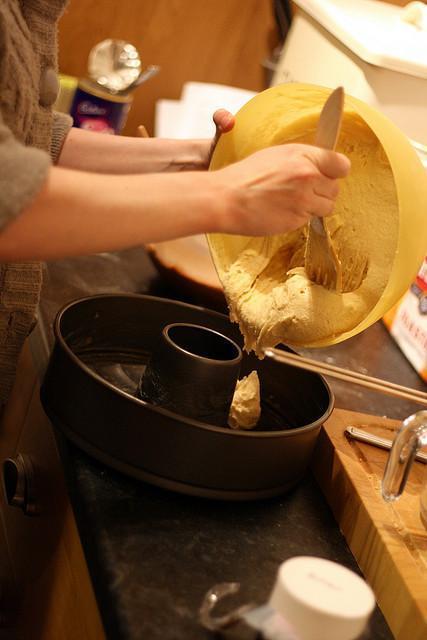How many bowls are there?
Give a very brief answer. 1. How many cows are directly facing the camera?
Give a very brief answer. 0. 